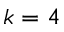Convert formula to latex. <formula><loc_0><loc_0><loc_500><loc_500>k = 4</formula> 